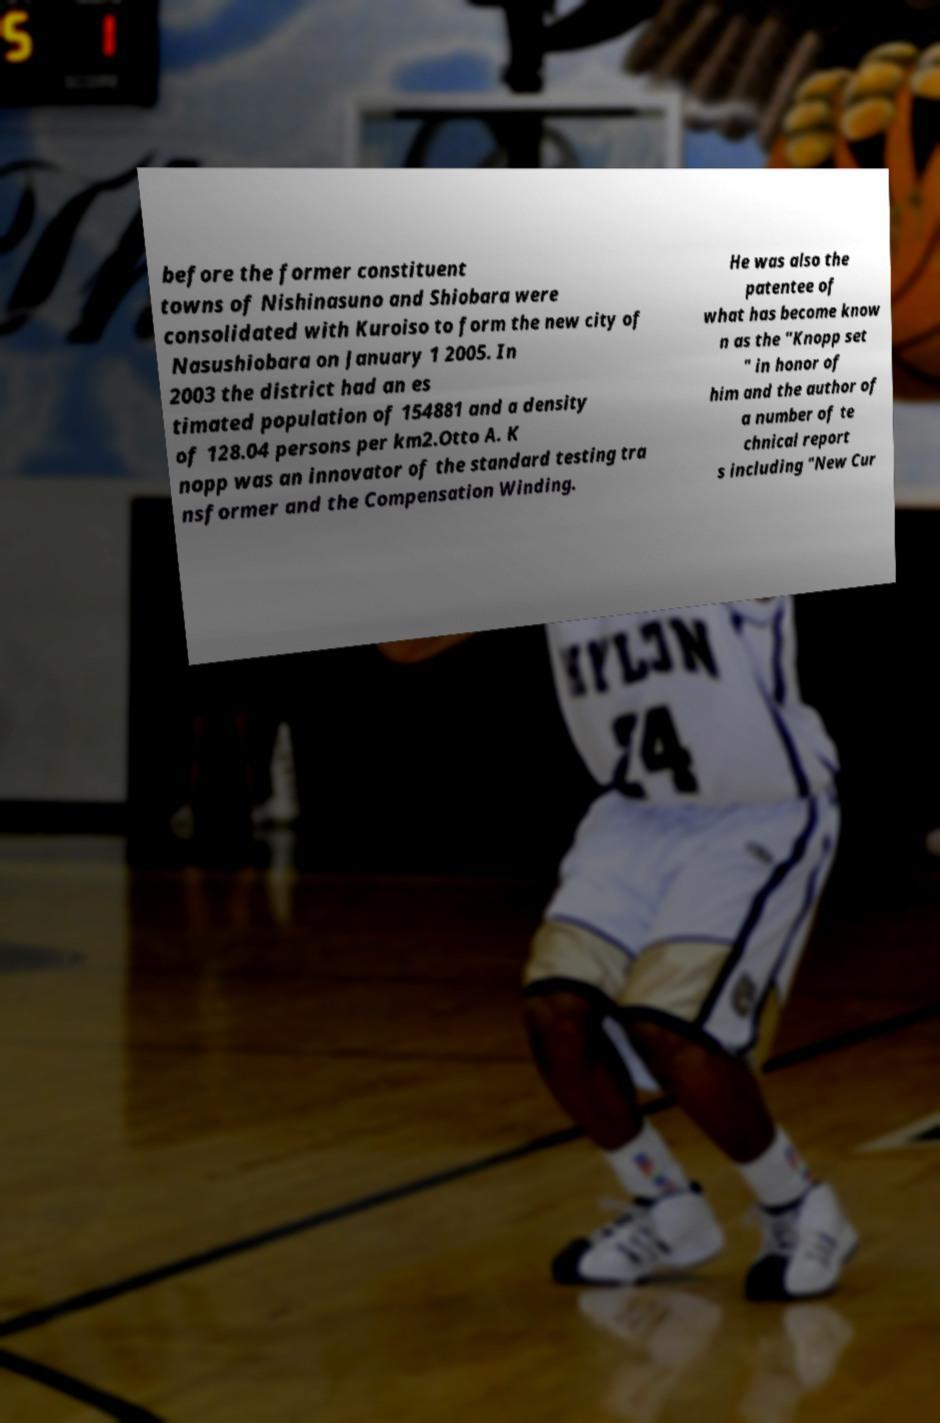There's text embedded in this image that I need extracted. Can you transcribe it verbatim? before the former constituent towns of Nishinasuno and Shiobara were consolidated with Kuroiso to form the new city of Nasushiobara on January 1 2005. In 2003 the district had an es timated population of 154881 and a density of 128.04 persons per km2.Otto A. K nopp was an innovator of the standard testing tra nsformer and the Compensation Winding. He was also the patentee of what has become know n as the "Knopp set " in honor of him and the author of a number of te chnical report s including "New Cur 